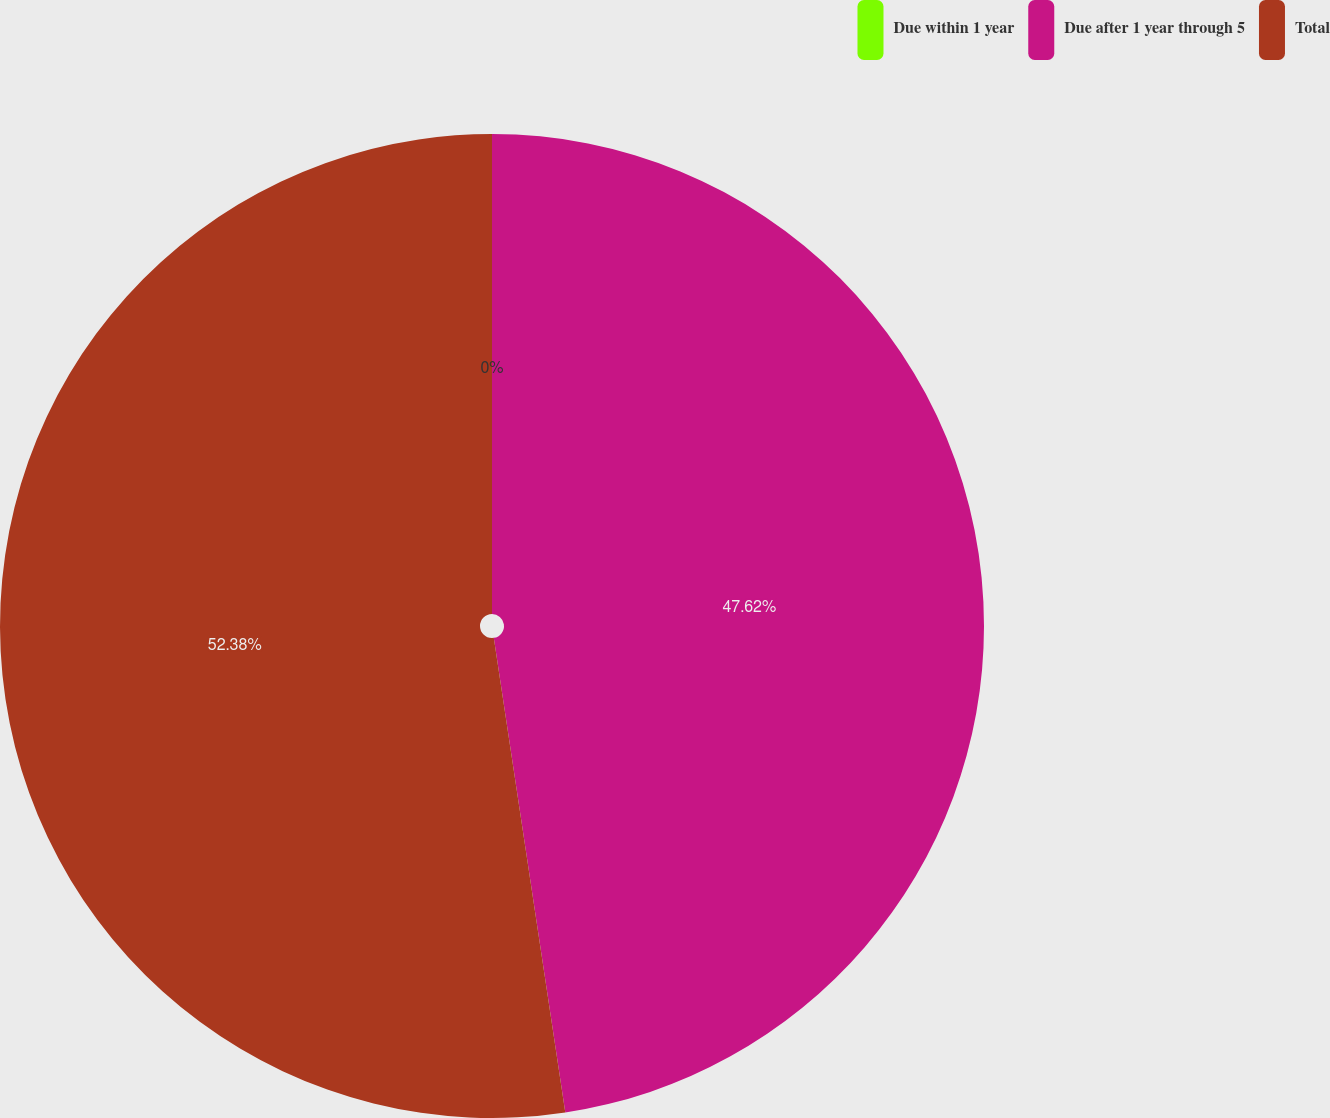<chart> <loc_0><loc_0><loc_500><loc_500><pie_chart><fcel>Due within 1 year<fcel>Due after 1 year through 5<fcel>Total<nl><fcel>0.0%<fcel>47.62%<fcel>52.38%<nl></chart> 